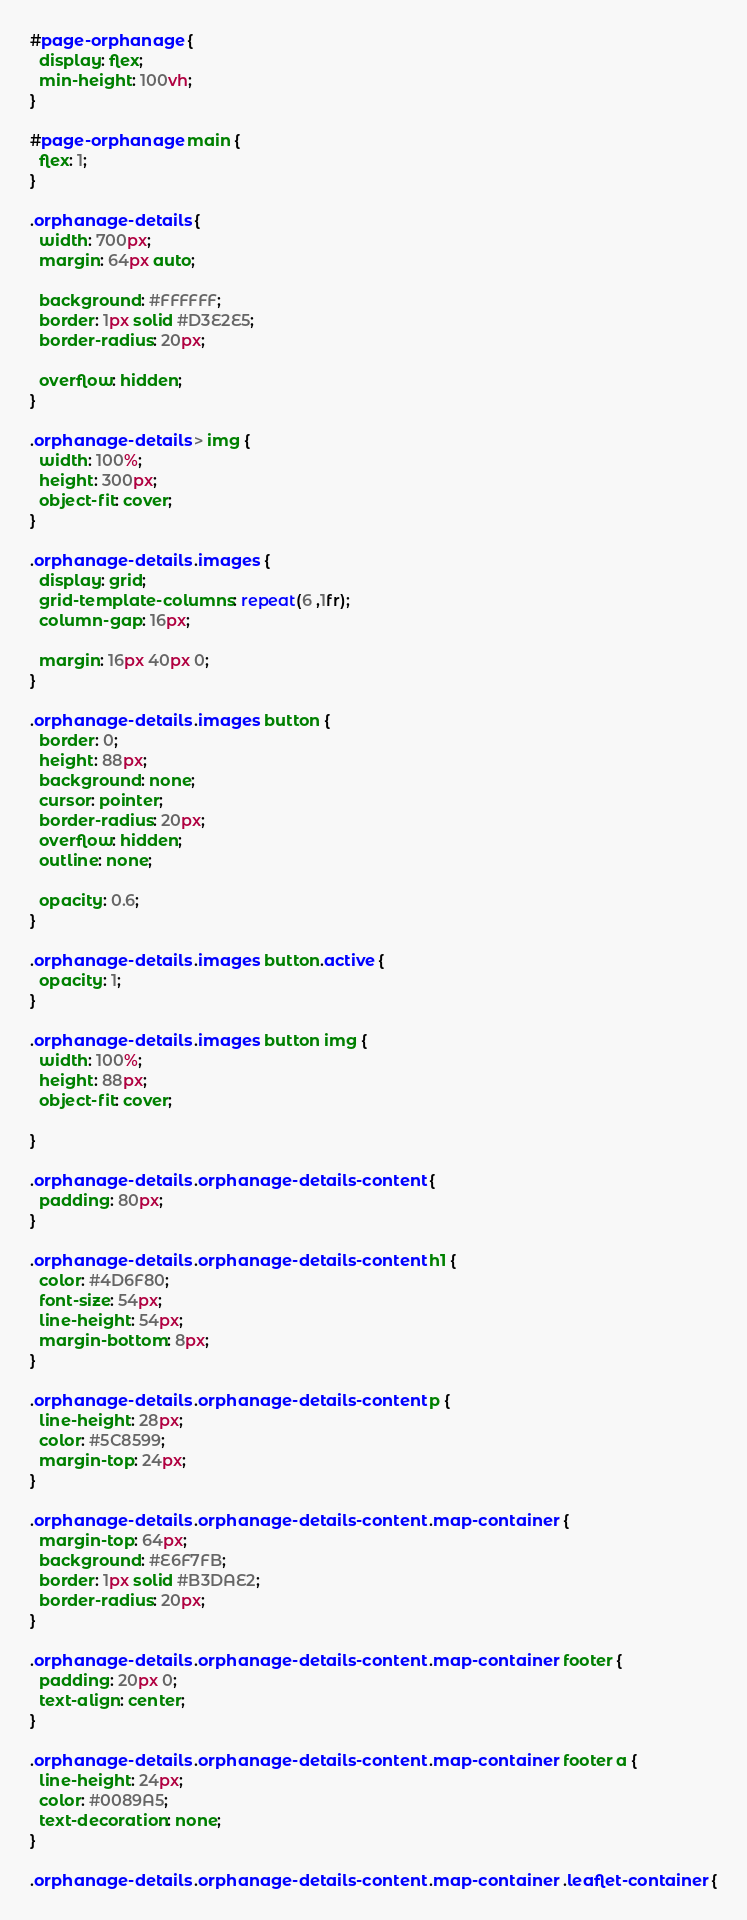<code> <loc_0><loc_0><loc_500><loc_500><_CSS_>#page-orphanage {
  display: flex;
  min-height: 100vh;
}

#page-orphanage main {
  flex: 1;
}

.orphanage-details {
  width: 700px;
  margin: 64px auto;

  background: #FFFFFF;
  border: 1px solid #D3E2E5;
  border-radius: 20px;

  overflow: hidden;
}

.orphanage-details > img {
  width: 100%;
  height: 300px;
  object-fit: cover;
}

.orphanage-details .images {
  display: grid;
  grid-template-columns: repeat(6 ,1fr);
  column-gap: 16px;

  margin: 16px 40px 0;
}
 
.orphanage-details .images button {
  border: 0;
  height: 88px;
  background: none;
  cursor: pointer;
  border-radius: 20px;
  overflow: hidden;
  outline: none;
  
  opacity: 0.6;
}

.orphanage-details .images button.active {
  opacity: 1;
}

.orphanage-details .images button img {
  width: 100%;
  height: 88px;
  object-fit: cover;
  
}

.orphanage-details .orphanage-details-content {
  padding: 80px;
}

.orphanage-details .orphanage-details-content h1 {
  color: #4D6F80;
  font-size: 54px;
  line-height: 54px;
  margin-bottom: 8px;
}

.orphanage-details .orphanage-details-content p {
  line-height: 28px;
  color: #5C8599;
  margin-top: 24px;
}

.orphanage-details .orphanage-details-content .map-container {
  margin-top: 64px;
  background: #E6F7FB;
  border: 1px solid #B3DAE2;
  border-radius: 20px;
}

.orphanage-details .orphanage-details-content .map-container footer {
  padding: 20px 0;
  text-align: center;
}

.orphanage-details .orphanage-details-content .map-container footer a {
  line-height: 24px;
  color: #0089A5;
  text-decoration: none;
}

.orphanage-details .orphanage-details-content .map-container .leaflet-container {</code> 